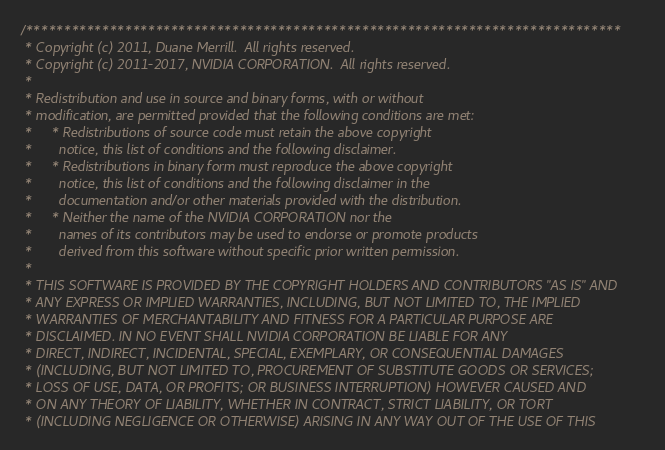<code> <loc_0><loc_0><loc_500><loc_500><_Cuda_>/******************************************************************************
 * Copyright (c) 2011, Duane Merrill.  All rights reserved.
 * Copyright (c) 2011-2017, NVIDIA CORPORATION.  All rights reserved.
 *
 * Redistribution and use in source and binary forms, with or without
 * modification, are permitted provided that the following conditions are met:
 *     * Redistributions of source code must retain the above copyright
 *       notice, this list of conditions and the following disclaimer.
 *     * Redistributions in binary form must reproduce the above copyright
 *       notice, this list of conditions and the following disclaimer in the
 *       documentation and/or other materials provided with the distribution.
 *     * Neither the name of the NVIDIA CORPORATION nor the
 *       names of its contributors may be used to endorse or promote products
 *       derived from this software without specific prior written permission.
 *
 * THIS SOFTWARE IS PROVIDED BY THE COPYRIGHT HOLDERS AND CONTRIBUTORS "AS IS" AND
 * ANY EXPRESS OR IMPLIED WARRANTIES, INCLUDING, BUT NOT LIMITED TO, THE IMPLIED
 * WARRANTIES OF MERCHANTABILITY AND FITNESS FOR A PARTICULAR PURPOSE ARE
 * DISCLAIMED. IN NO EVENT SHALL NVIDIA CORPORATION BE LIABLE FOR ANY
 * DIRECT, INDIRECT, INCIDENTAL, SPECIAL, EXEMPLARY, OR CONSEQUENTIAL DAMAGES
 * (INCLUDING, BUT NOT LIMITED TO, PROCUREMENT OF SUBSTITUTE GOODS OR SERVICES;
 * LOSS OF USE, DATA, OR PROFITS; OR BUSINESS INTERRUPTION) HOWEVER CAUSED AND
 * ON ANY THEORY OF LIABILITY, WHETHER IN CONTRACT, STRICT LIABILITY, OR TORT
 * (INCLUDING NEGLIGENCE OR OTHERWISE) ARISING IN ANY WAY OUT OF THE USE OF THIS</code> 